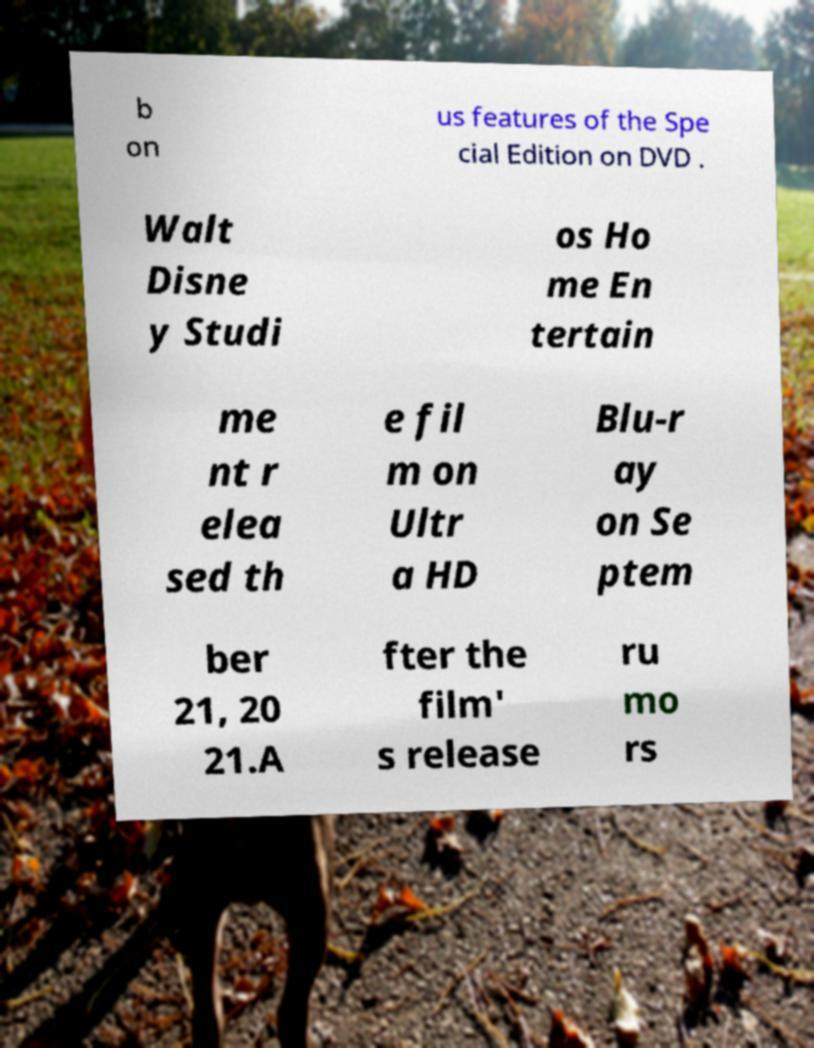I need the written content from this picture converted into text. Can you do that? b on us features of the Spe cial Edition on DVD . Walt Disne y Studi os Ho me En tertain me nt r elea sed th e fil m on Ultr a HD Blu-r ay on Se ptem ber 21, 20 21.A fter the film' s release ru mo rs 